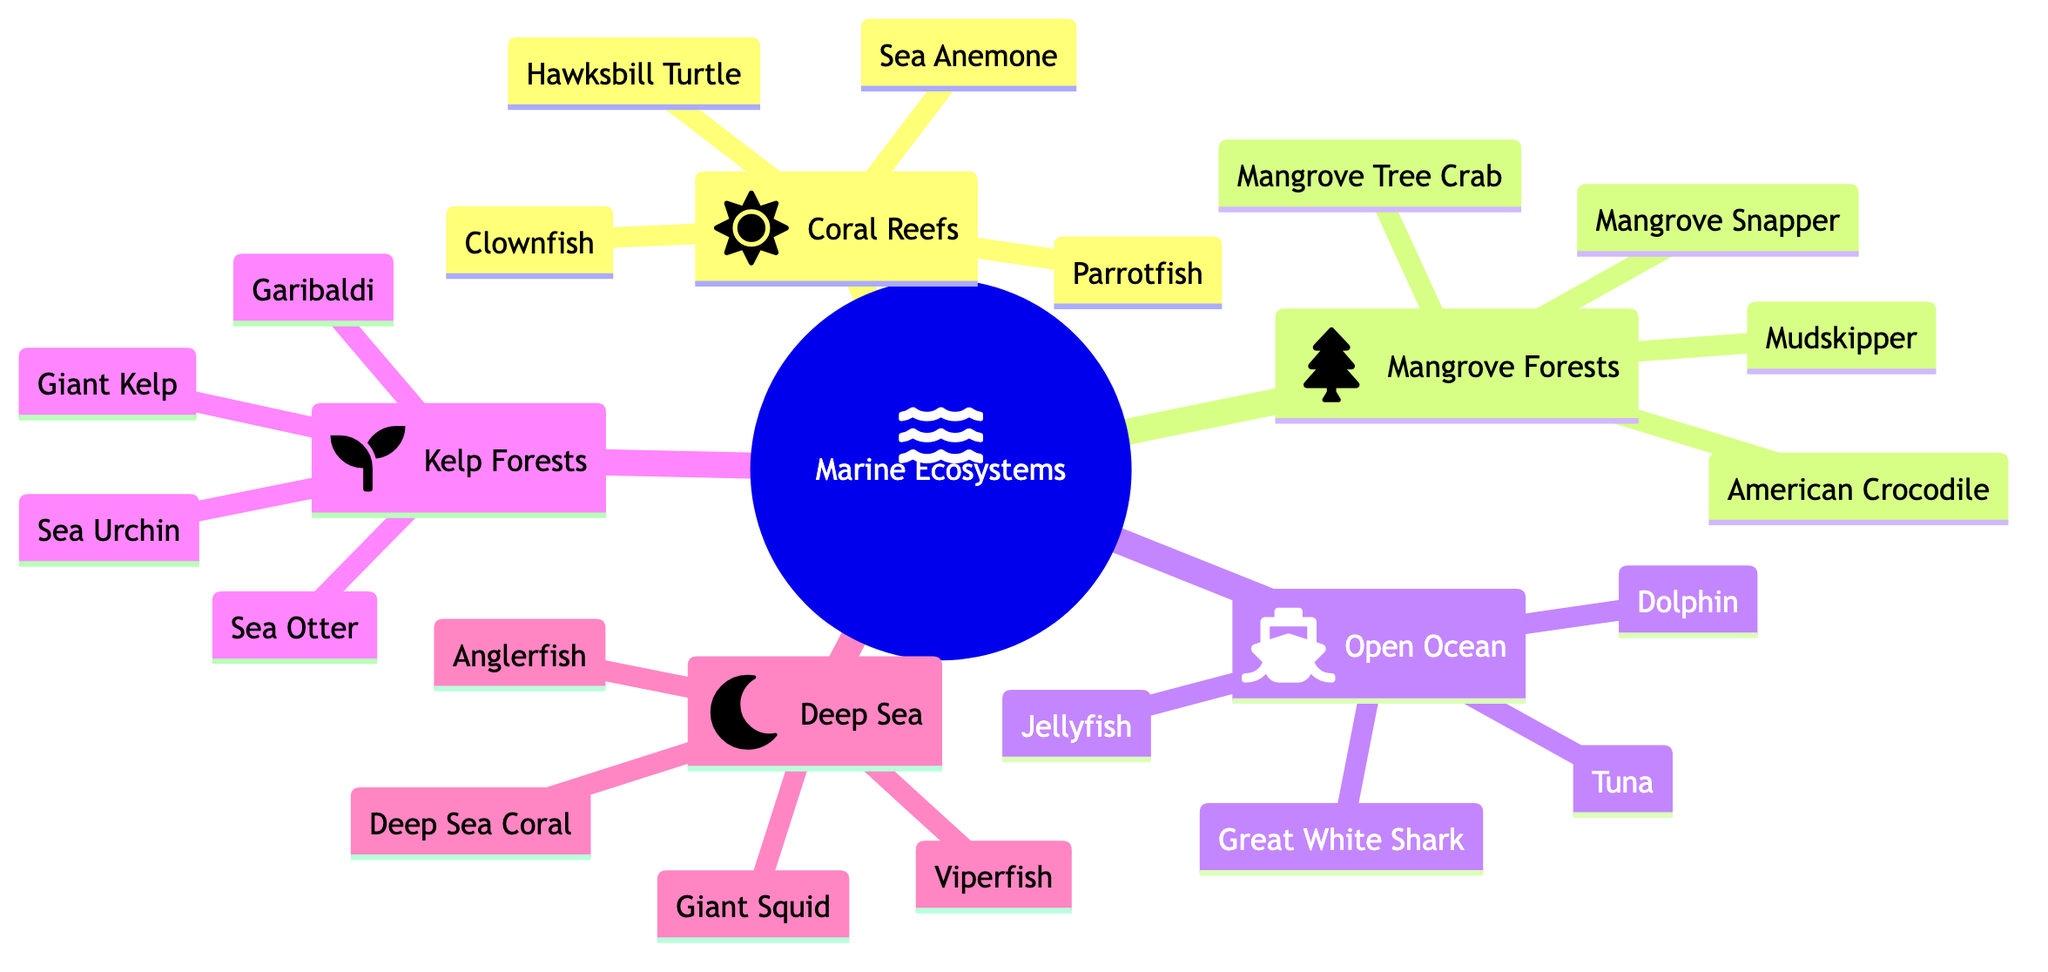What are the names of two representative species in Coral Reefs? In the Coral Reefs section of the diagram, the representative species listed include Clownfish and Sea Anemone. This involves directly extracting the names of two species mentioned under this specific node.
Answer: Clownfish, Sea Anemone How many different marine ecosystems are represented in the diagram? By counting the main nodes branching from the root "Marine Ecosystems," we find that there are five ecosystems: Coral Reefs, Mangrove Forests, Open Ocean, Kelp Forests, and Deep Sea. This requires a simple tally of the nodes shown in the diagram.
Answer: 5 Which ecosystem includes the Great White Shark? In the Open Ocean section of the diagram, the Great White Shark is listed as one of its representative species. This requires identifying the specific ecosystem node where this species is mentioned.
Answer: Open Ocean What species is unique to the Kelp Forests ecosystem compared to others? The species Giant Kelp is specifically listed under the Kelp Forests section and does not appear in any of the other ecosystems. This requires comparing species across the different ecosystems to identify one that is unique.
Answer: Giant Kelp Which two species can be found in the Deep Sea ecosystem? From the Deep Sea section, two of the species listed are Anglerfish and Giant Squid. This involves extracting the names of any two species found specifically under the Deep Sea node.
Answer: Anglerfish, Giant Squid How many species are associated with Mangrove Forests? Under the Mangrove Forests section, the number of species listed includes four: Mangrove Tree Crab, American Crocodile, Mudskipper, and Mangrove Snapper. This requires counting the species listed beneath the Mangrove Forests node.
Answer: 4 Which ecosystem has the species Sea Otter? The species Sea Otter is found in the Kelp Forests ecosystem. This requires locating the Sea Otter in the diagram and identifying the ecosystem to which it belongs.
Answer: Kelp Forests What is the relationship between Coral Reefs and the Hawksbill Turtle? The Hawksbill Turtle is a representative species found within the Coral Reefs ecosystem. This requires understanding that the Hawksbill Turtle is part of the Coral Reefs node, indicating a direct connection.
Answer: Hawksbill Turtle is in Coral Reefs Which ecosystem is the most diverse in species representation based on the diagram? By comparing the species listed across all ecosystems, Kelp Forests has four species: Sea Otter, Garibaldi, Giant Kelp, and Sea Urchin, while others vary in number. This requires analyzing each ecosystem's species count to determine which has the most representatives.
Answer: Kelp Forests 